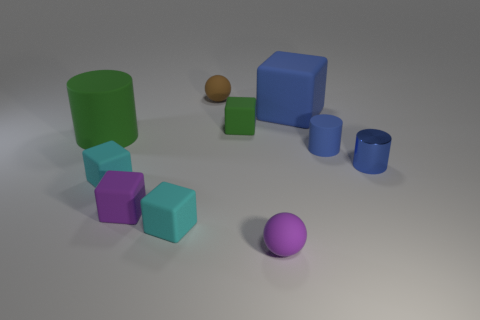Are there fewer small green things than spheres?
Offer a terse response. Yes. What number of other objects are the same material as the big blue thing?
Ensure brevity in your answer.  8. There is another object that is the same shape as the brown thing; what is its size?
Your answer should be compact. Small. Does the small thing that is behind the blue rubber cube have the same material as the blue cylinder behind the small blue metal object?
Your answer should be compact. Yes. Are there fewer small brown matte balls that are in front of the brown object than purple matte blocks?
Offer a very short reply. Yes. Are there any other things that have the same shape as the large blue object?
Provide a succinct answer. Yes. There is another small matte thing that is the same shape as the small brown thing; what color is it?
Offer a terse response. Purple. Do the rubber ball that is in front of the blue rubber cylinder and the purple matte cube have the same size?
Make the answer very short. Yes. What size is the rubber block in front of the small purple matte object that is to the left of the green matte cube?
Your answer should be very brief. Small. Is the tiny brown sphere made of the same material as the cylinder that is on the left side of the small brown sphere?
Your answer should be compact. Yes. 